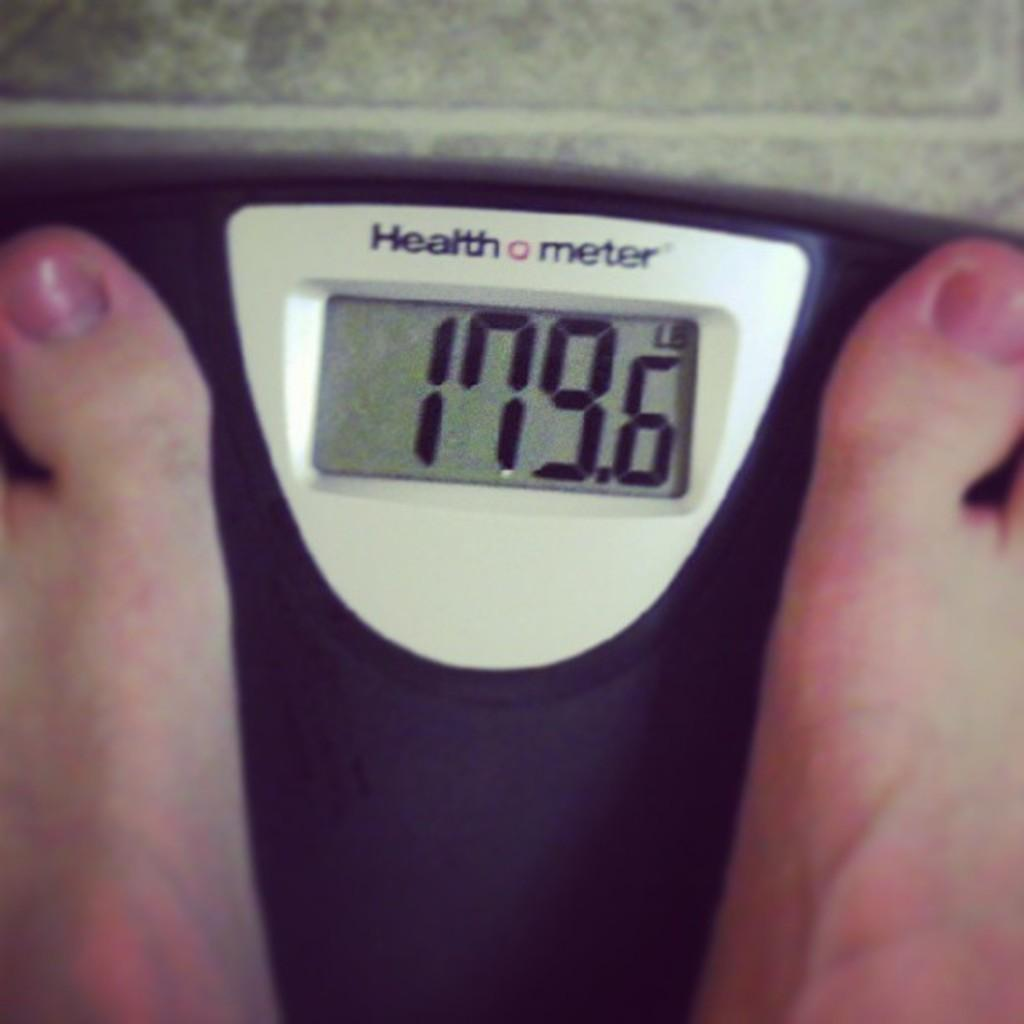<image>
Provide a brief description of the given image. A health meter scale displays someone's weight in pounds. 